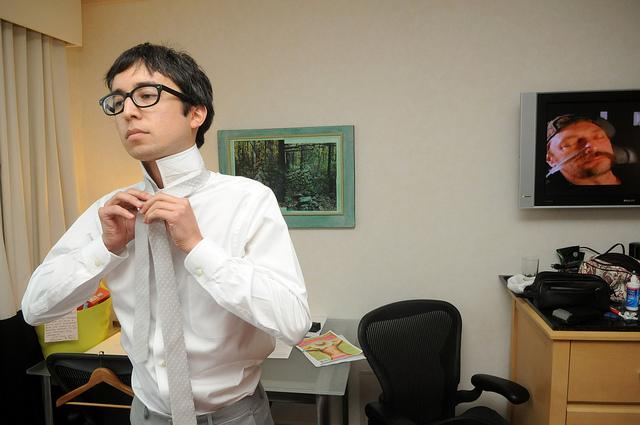What color theme is the man with the the tie trying to achieve with his outfit? white 